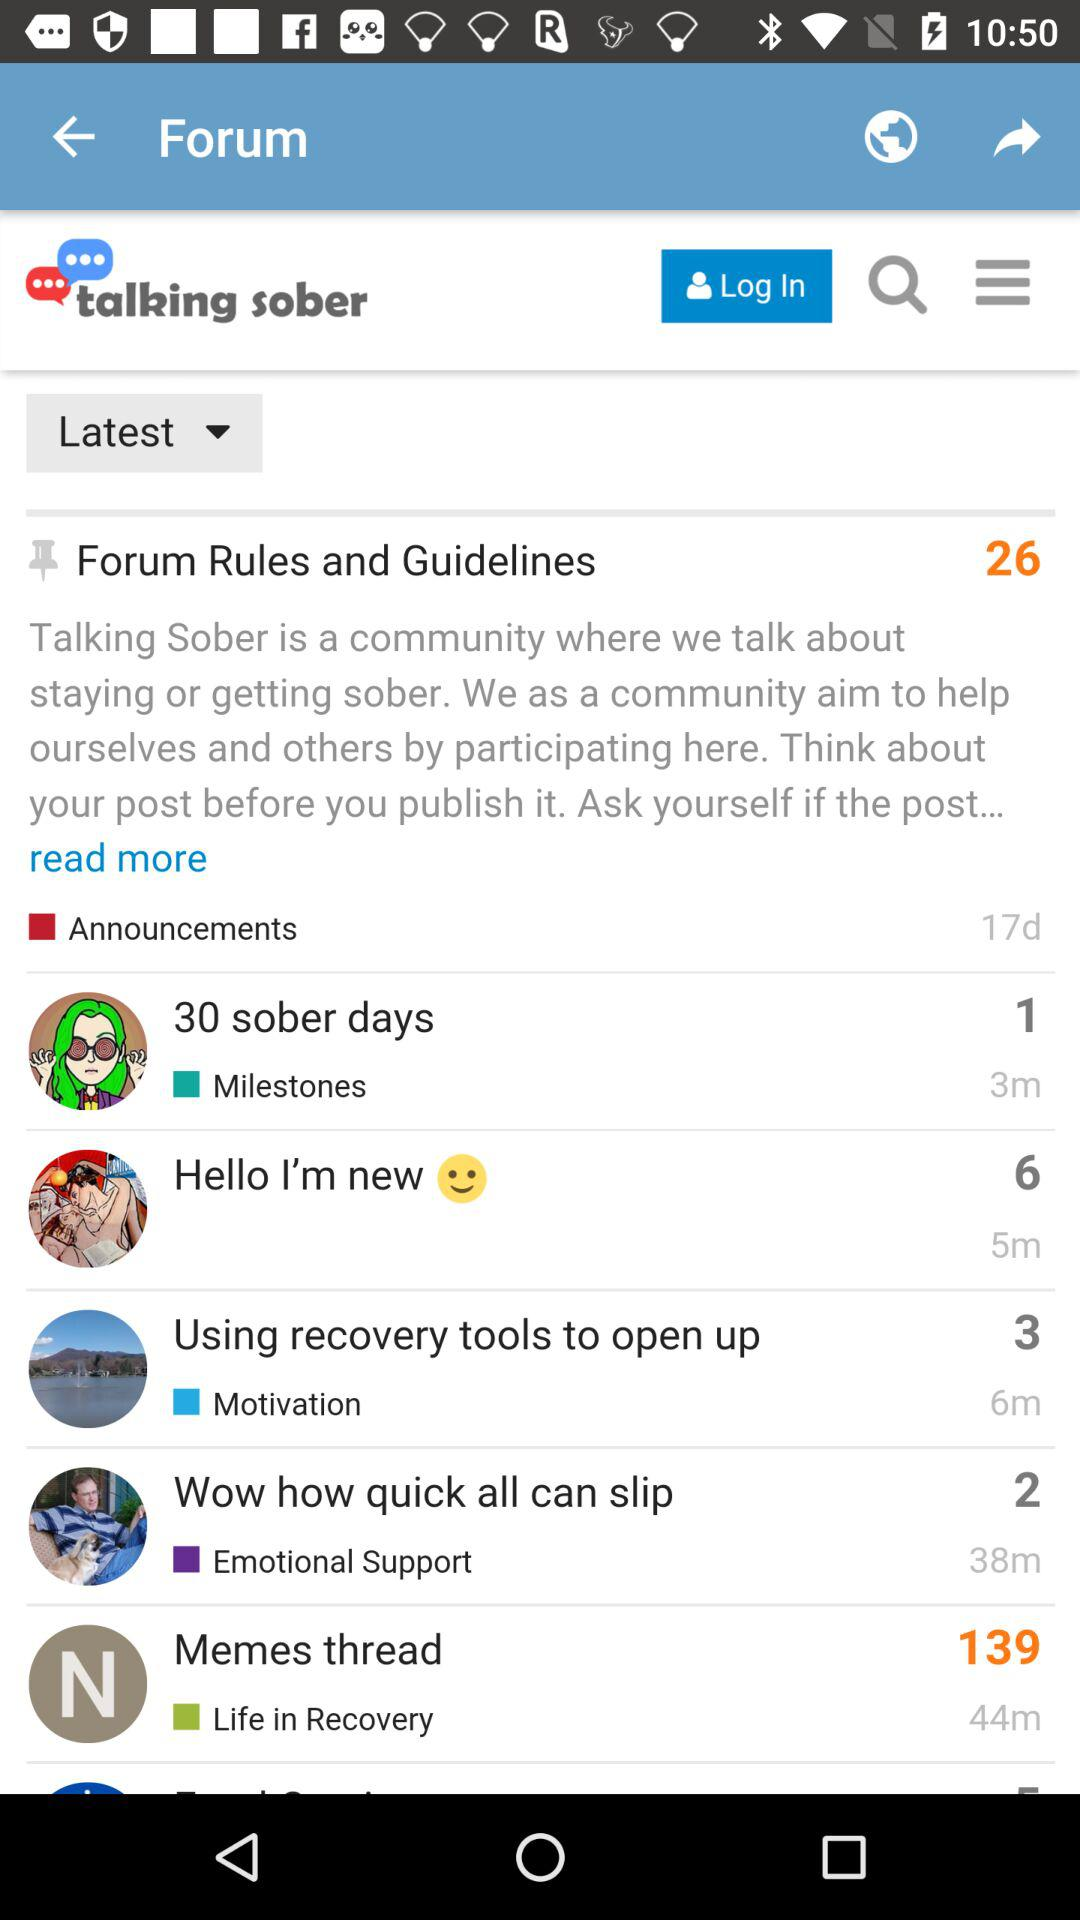Who is having the highest number of announcements?
When the provided information is insufficient, respond with <no answer>. <no answer> 